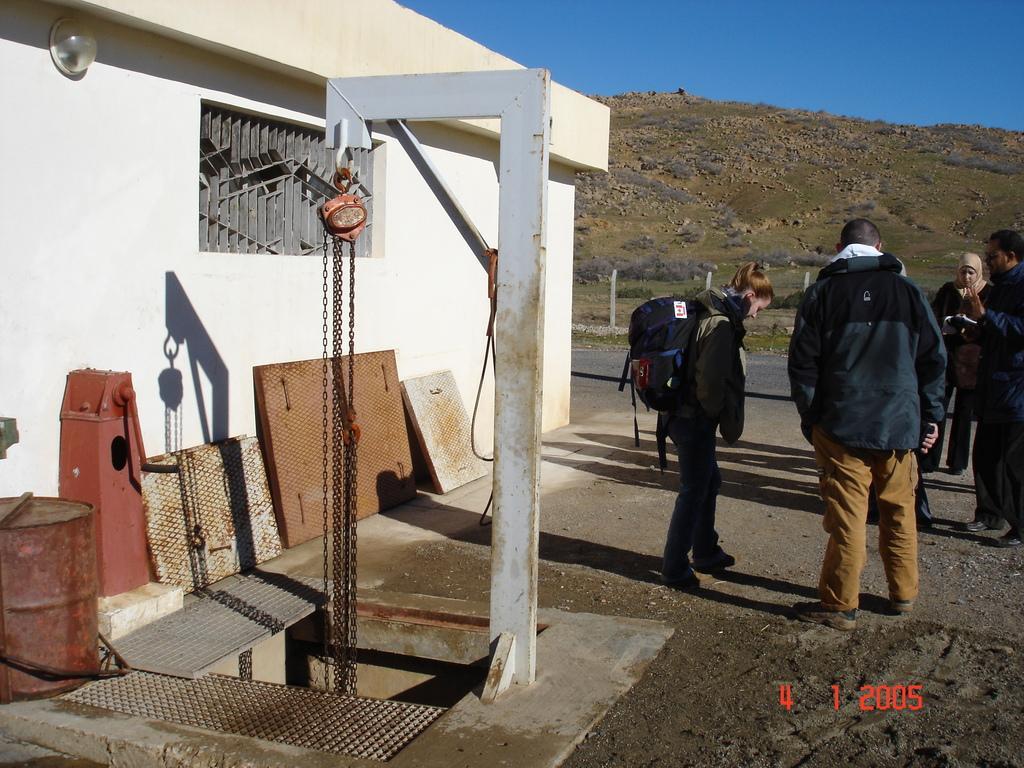How would you summarize this image in a sentence or two? In this image we can see some persons, iron objects, wall, light, window and other objects. At the bottom of the image there is the floor. In the background of the image there are rocks, grass and other objects. At the top of the image there is the sky. On the image there is a watermark. 